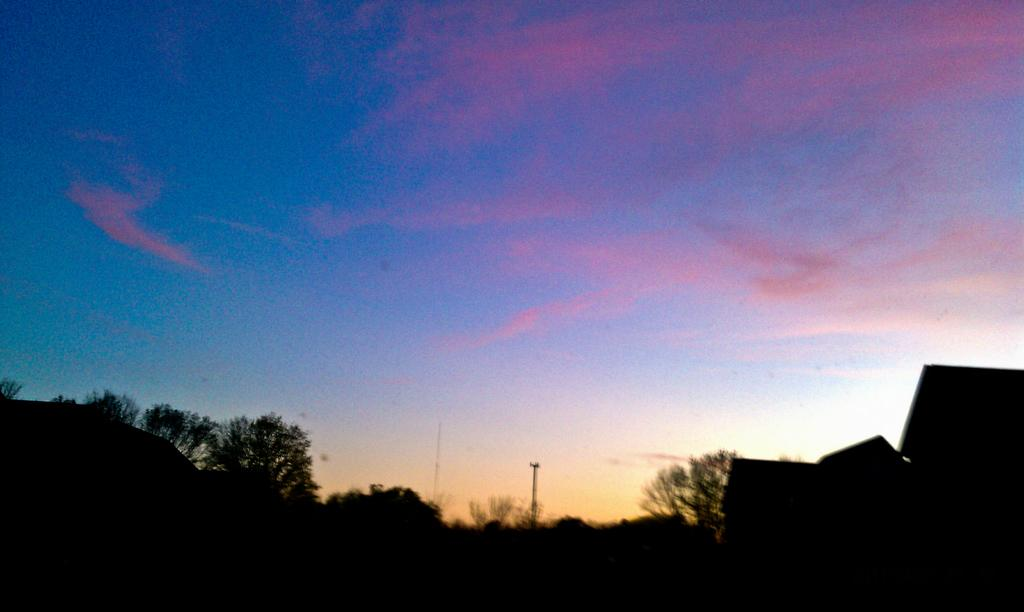What type of vegetation can be seen in the image? There are trees in the image. What type of infrastructure is present in the image? There is a current pole and buildings in the image. What is visible at the top of the image? The sky is visible at the top of the image. How would you describe the lighting in the image? The image appears to be slightly dark. How much sugar is present in the shade of the current pole in the image? There is no sugar or shade mentioned in the image; it features trees, a current pole, buildings, and a sky. What type of shock can be seen in the image? There is no shock present in the image; it is a scene with trees, a current pole, buildings, and a sky. 